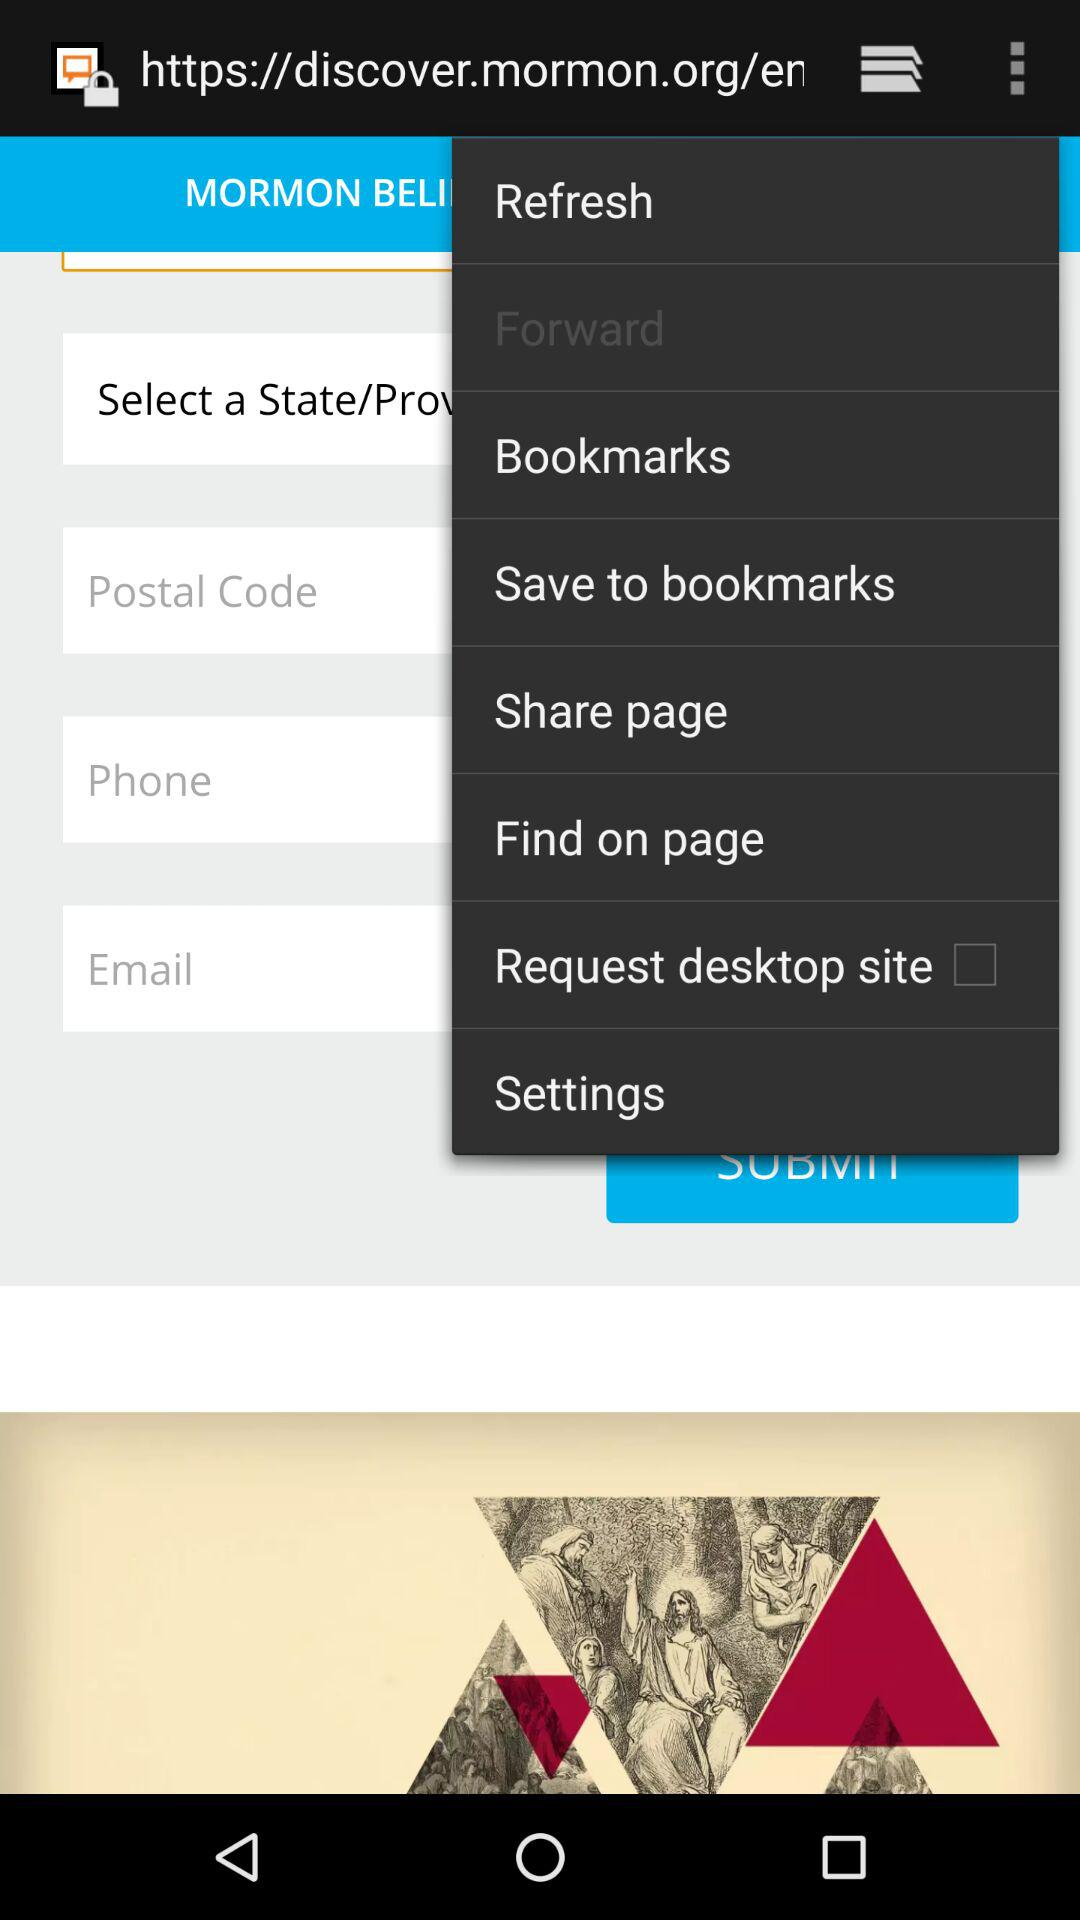How many more text inputs are there than checkboxes on this screen?
Answer the question using a single word or phrase. 3 